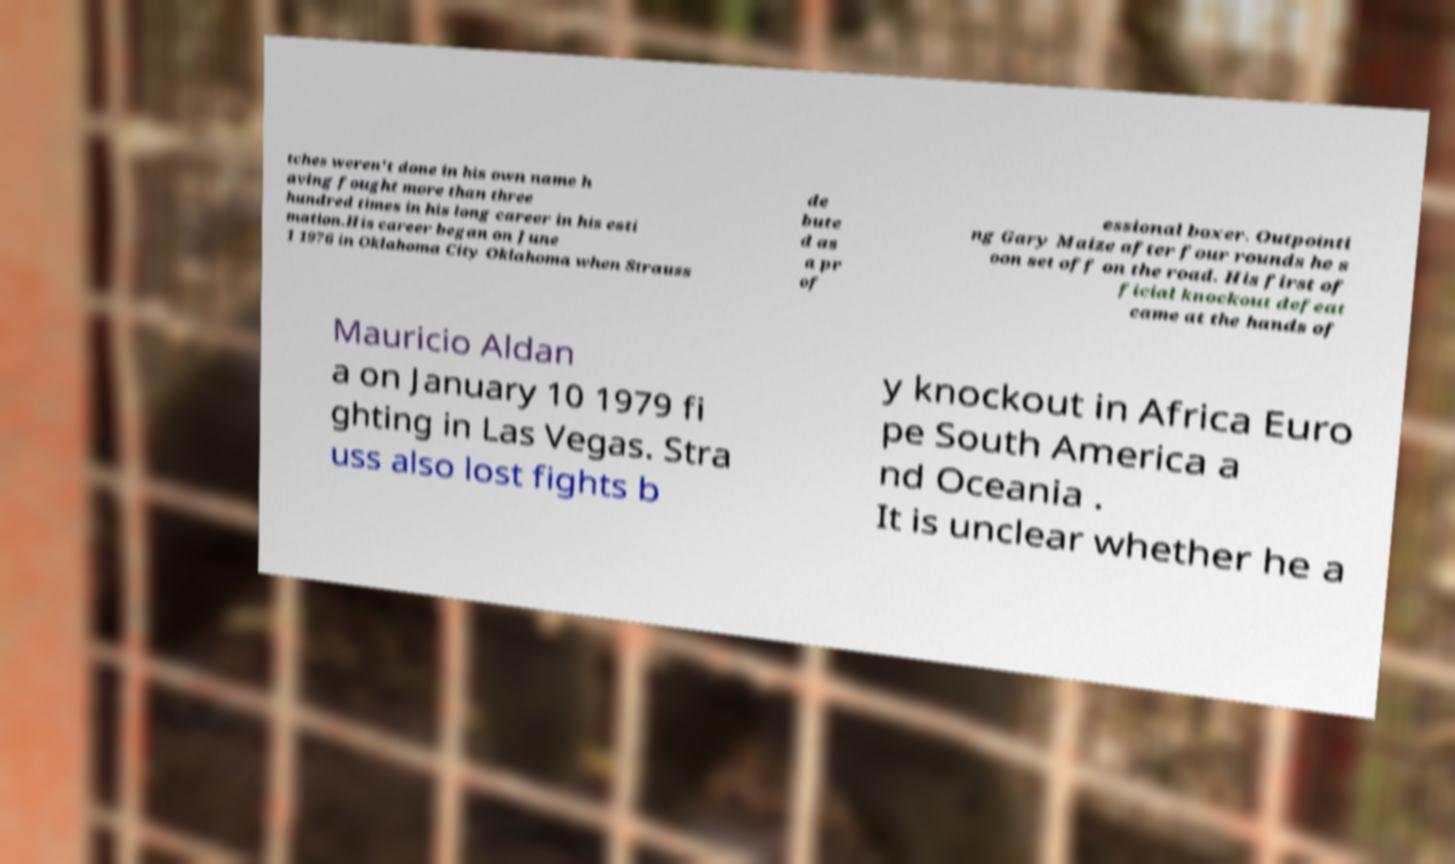For documentation purposes, I need the text within this image transcribed. Could you provide that? tches weren't done in his own name h aving fought more than three hundred times in his long career in his esti mation.His career began on June 1 1976 in Oklahoma City Oklahoma when Strauss de bute d as a pr of essional boxer. Outpointi ng Gary Maize after four rounds he s oon set off on the road. His first of ficial knockout defeat came at the hands of Mauricio Aldan a on January 10 1979 fi ghting in Las Vegas. Stra uss also lost fights b y knockout in Africa Euro pe South America a nd Oceania . It is unclear whether he a 